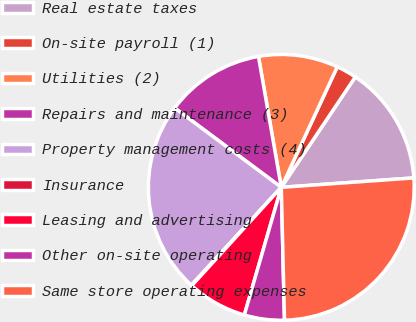<chart> <loc_0><loc_0><loc_500><loc_500><pie_chart><fcel>Real estate taxes<fcel>On-site payroll (1)<fcel>Utilities (2)<fcel>Repairs and maintenance (3)<fcel>Property management costs (4)<fcel>Insurance<fcel>Leasing and advertising<fcel>Other on-site operating<fcel>Same store operating expenses<nl><fcel>14.47%<fcel>2.48%<fcel>9.67%<fcel>12.07%<fcel>23.35%<fcel>0.08%<fcel>7.27%<fcel>4.87%<fcel>25.75%<nl></chart> 